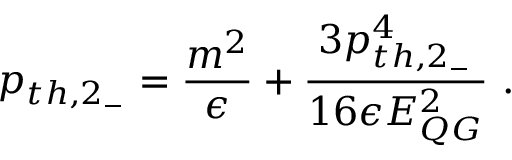Convert formula to latex. <formula><loc_0><loc_0><loc_500><loc_500>p _ { t h , 2 _ { - } } = { \frac { m ^ { 2 } } { \epsilon } } + { \frac { 3 p _ { t h , 2 _ { - } } ^ { 4 } } { 1 6 \epsilon E _ { Q G } ^ { 2 } } } .</formula> 